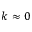<formula> <loc_0><loc_0><loc_500><loc_500>k \approx 0</formula> 